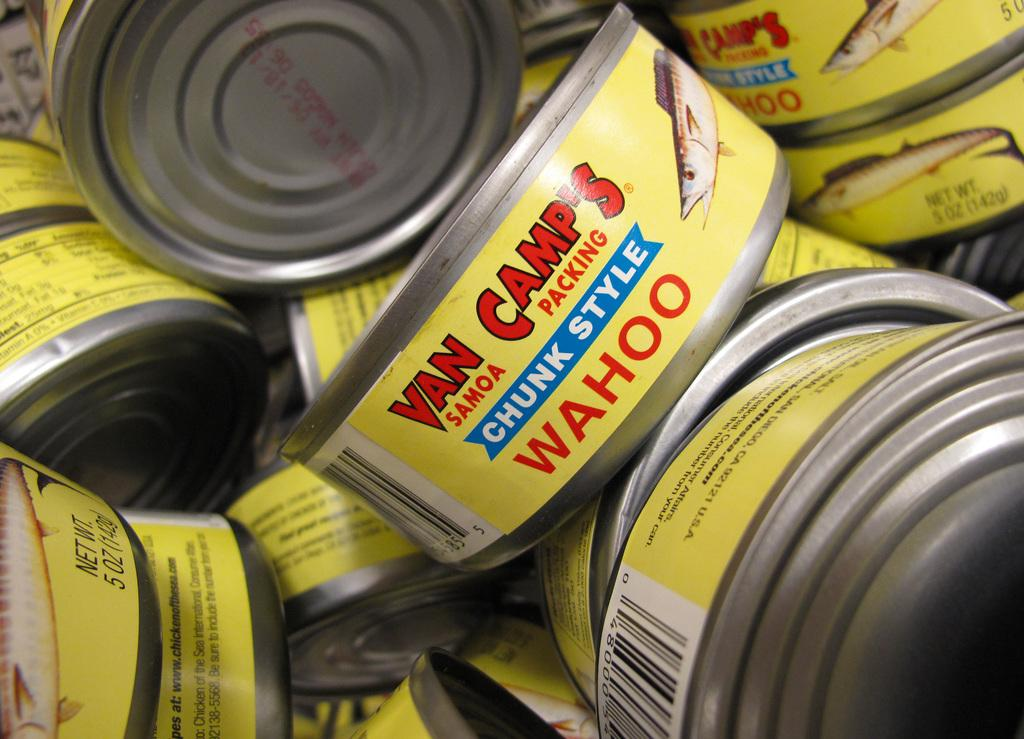<image>
Give a short and clear explanation of the subsequent image. Several yellow Van Camp's chunk style wahoo cans together. 